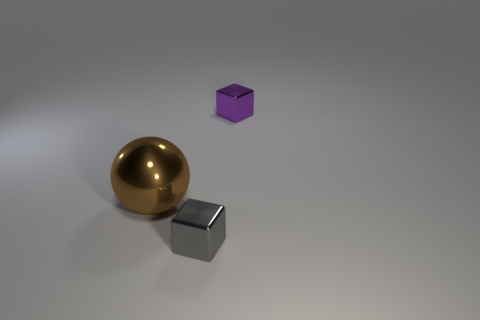Subtract all purple blocks. How many blocks are left? 1 Add 3 large green metallic balls. How many objects exist? 6 Subtract all cubes. How many objects are left? 1 Subtract all yellow spheres. How many cyan blocks are left? 0 Subtract 0 blue cylinders. How many objects are left? 3 Subtract all cyan spheres. Subtract all red cylinders. How many spheres are left? 1 Subtract all yellow metallic cylinders. Subtract all shiny things. How many objects are left? 0 Add 1 gray blocks. How many gray blocks are left? 2 Add 3 small things. How many small things exist? 5 